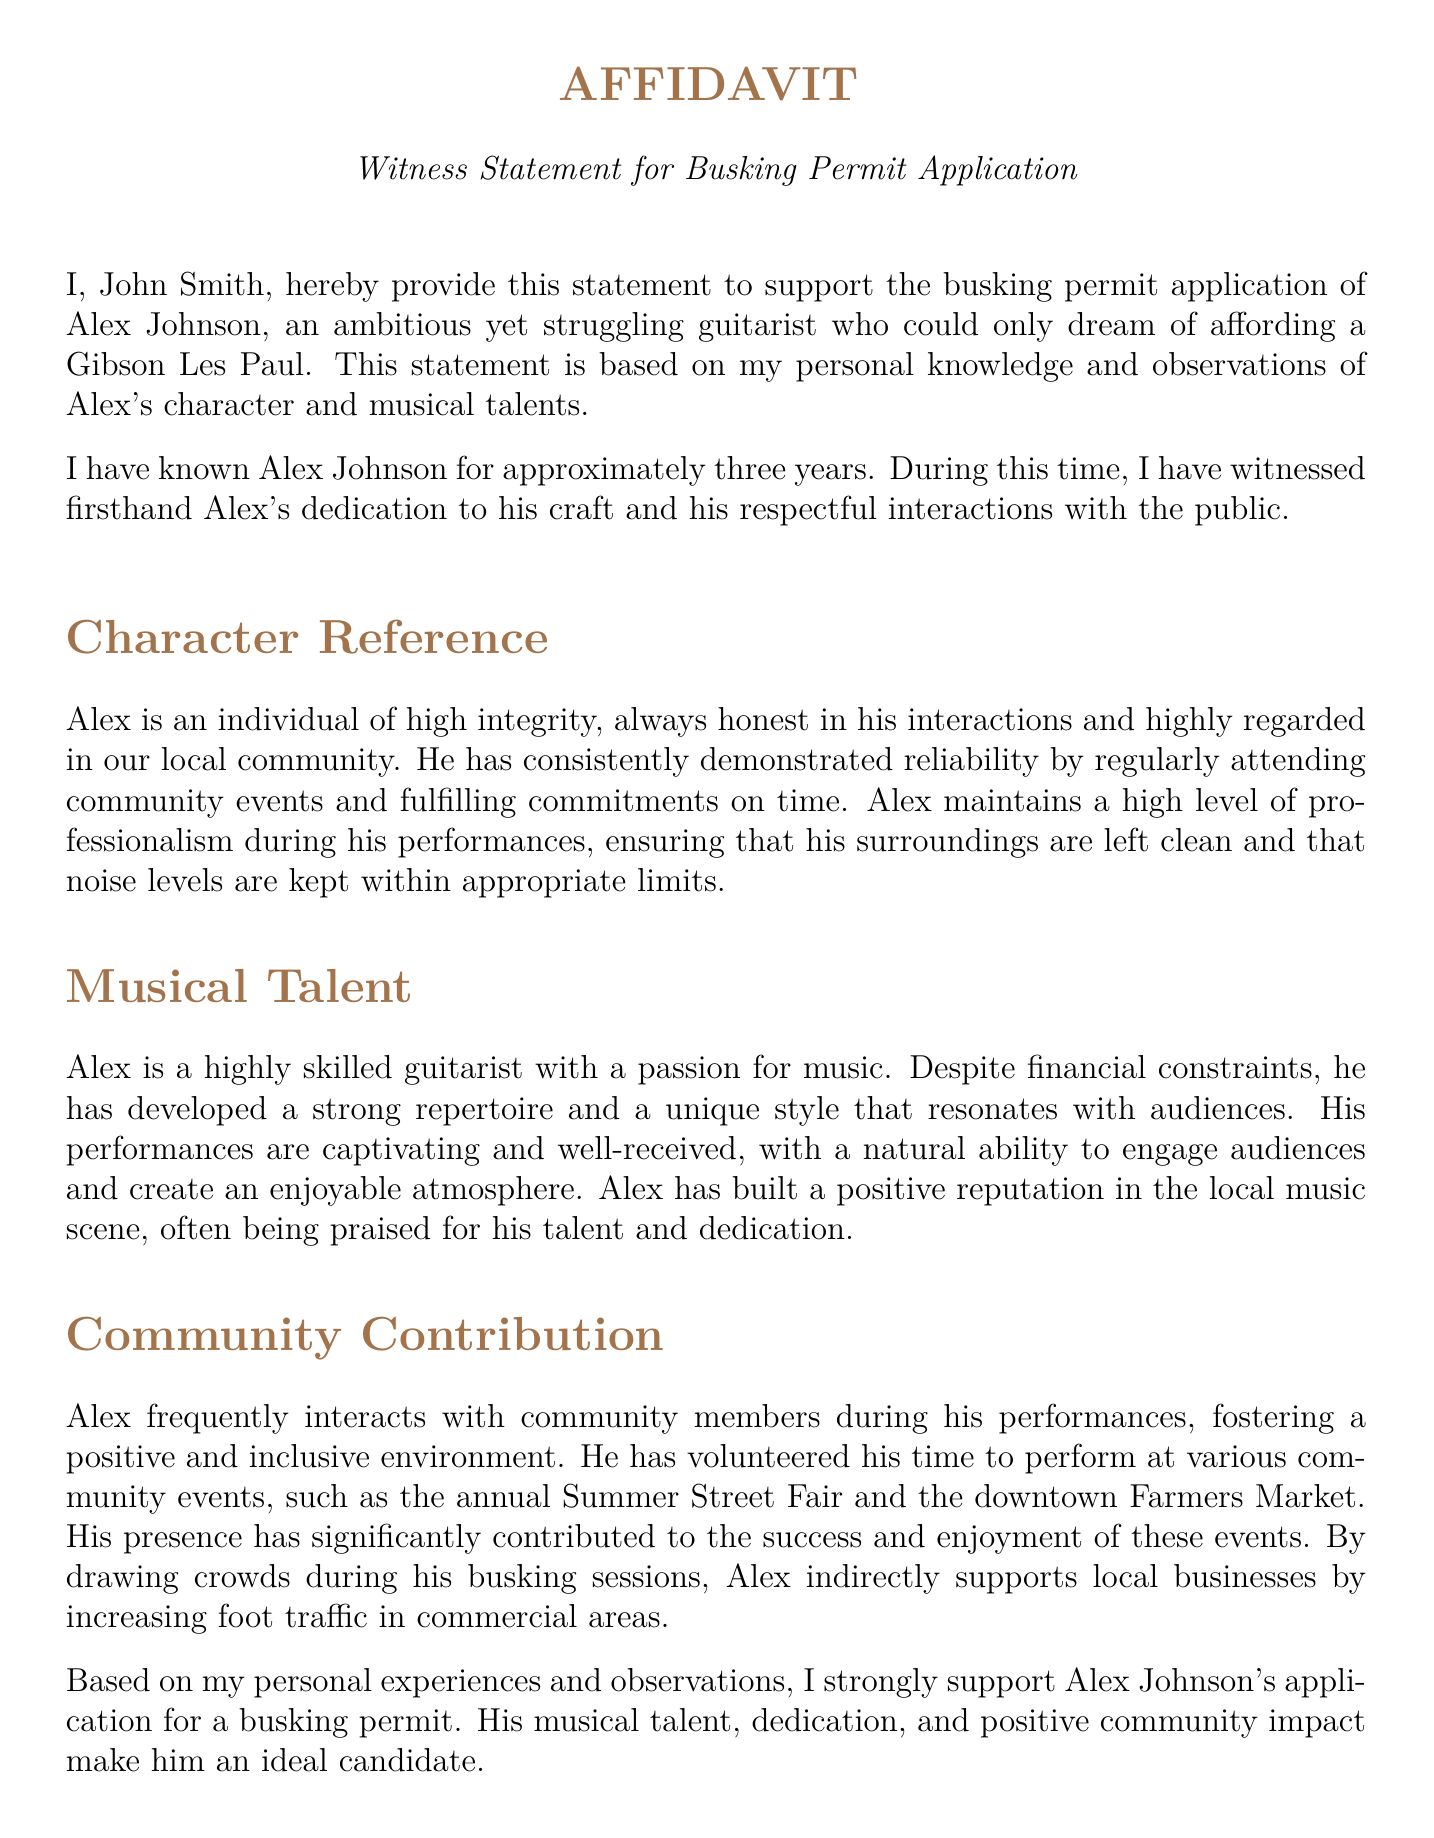What is the name of the witness? The witness's name is stated at the beginning of the document, which is John Smith.
Answer: John Smith How long has the witness known Alex Johnson? The document specifies the duration of the witness's acquaintance with Alex Johnson as approximately three years.
Answer: three years What is Alex Johnson described as? Alex Johnson is described in the affidavit as an "ambitious yet struggling guitarist."
Answer: ambitious yet struggling guitarist What community events has Alex performed at? The document lists specific community events where Alex has volunteered to perform, namely the annual Summer Street Fair and the downtown Farmers Market.
Answer: Summer Street Fair and Farmers Market What is the date of the affidavit? The date noted in the document is October 20, 2023.
Answer: October 20, 2023 What does the witness express for Alex's application? The witness strongly supports Alex Johnson's application for a busking permit, indicating his approval and endorsement.
Answer: strongly support How is Alex's musical talent characterized? The affidavit describes Alex's musical talent as "highly skilled" and emphasizes his passion for music.
Answer: highly skilled What impact does Alex have on local businesses? The document states that Alex's performances draw crowds and increase foot traffic in commercial areas, indirectly supporting local businesses.
Answer: increase foot traffic What is the address of the witness? The witness provides a specific address in the affidavit, which is 123 Main Street, Springfield, IL 62701.
Answer: 123 Main Street, Springfield, IL 62701 